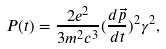Convert formula to latex. <formula><loc_0><loc_0><loc_500><loc_500>P ( t ) = \frac { 2 e ^ { 2 } } { 3 m ^ { 2 } c ^ { 3 } } ( \frac { d \vec { p } } { d t } ) ^ { 2 } \gamma ^ { 2 } ,</formula> 